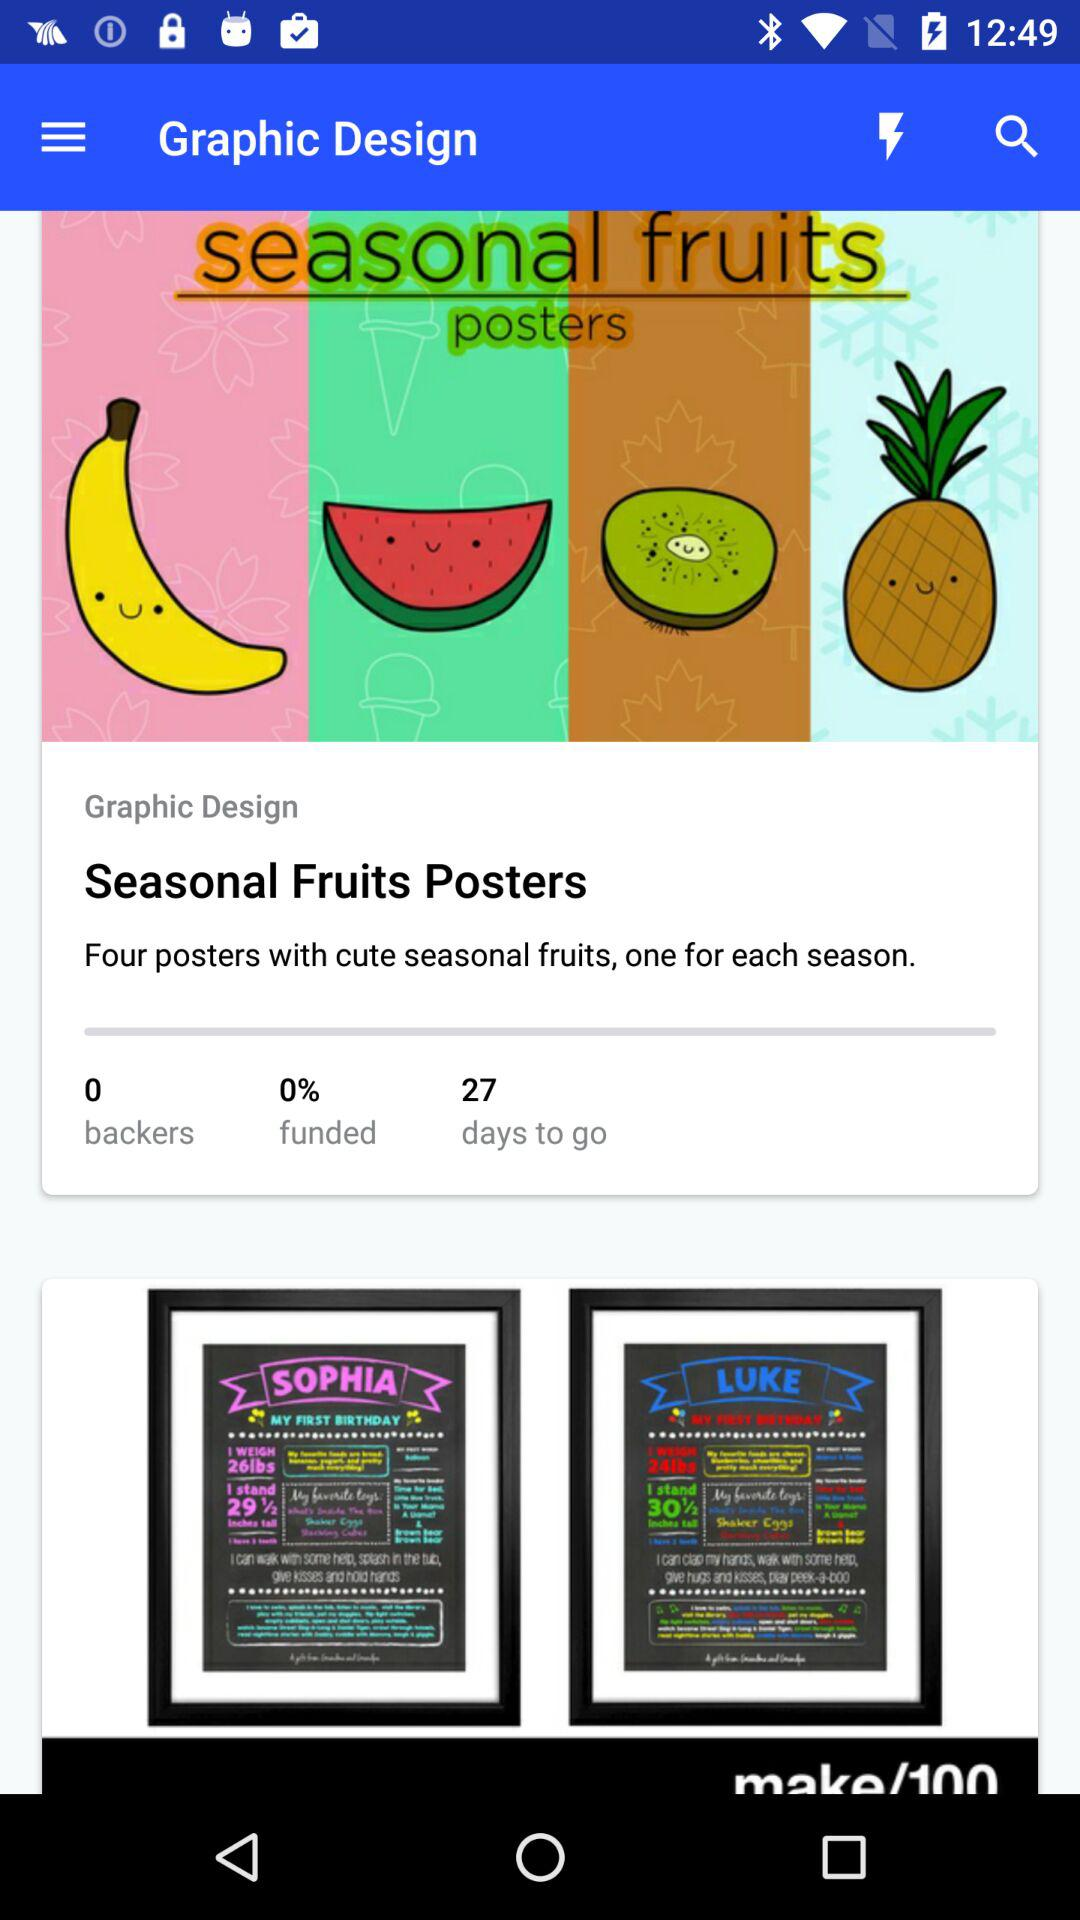What is the count of the posters?
Answer the question using a single word or phrase. The count of the posters is four 